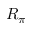Convert formula to latex. <formula><loc_0><loc_0><loc_500><loc_500>R _ { \pi }</formula> 